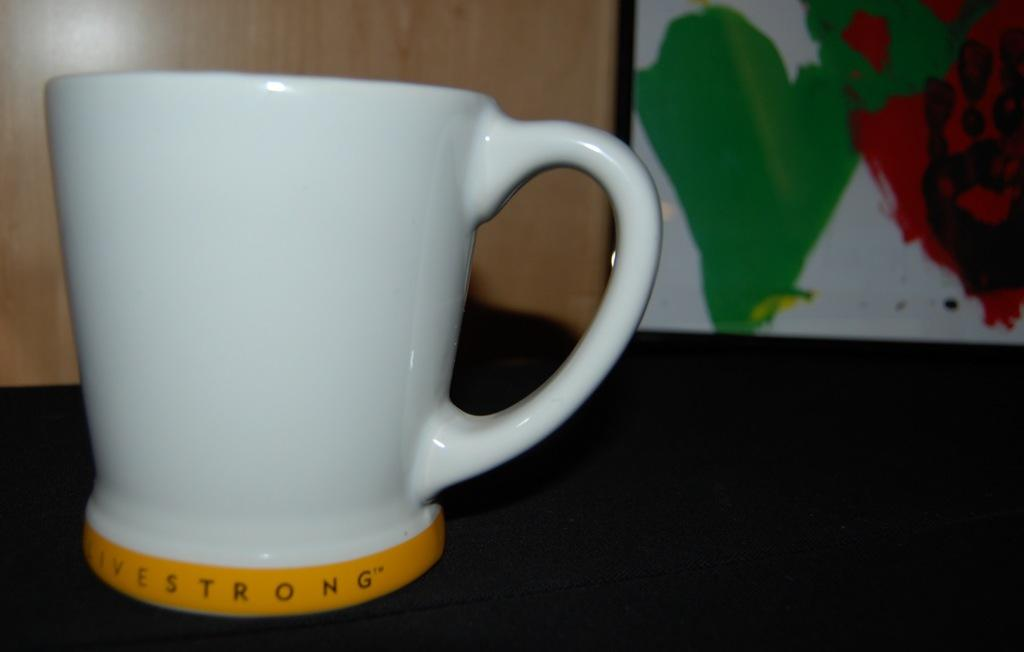What object is visible in the image that can hold liquids? There is a cup in the image that can hold liquids. Where is the cup located in the image? The cup is placed on a table in the image. What is the color of the cup? The cup is white in color. What type of artwork is present in the image? There is a painting in the image. On which side of the image is the painting located? The painting is on the right side of the image. What colors are used in the painting? The painting has green and red colors. How does the bit of the painting move in the image? There is no bit of the painting moving in the image; it is a static painting. 